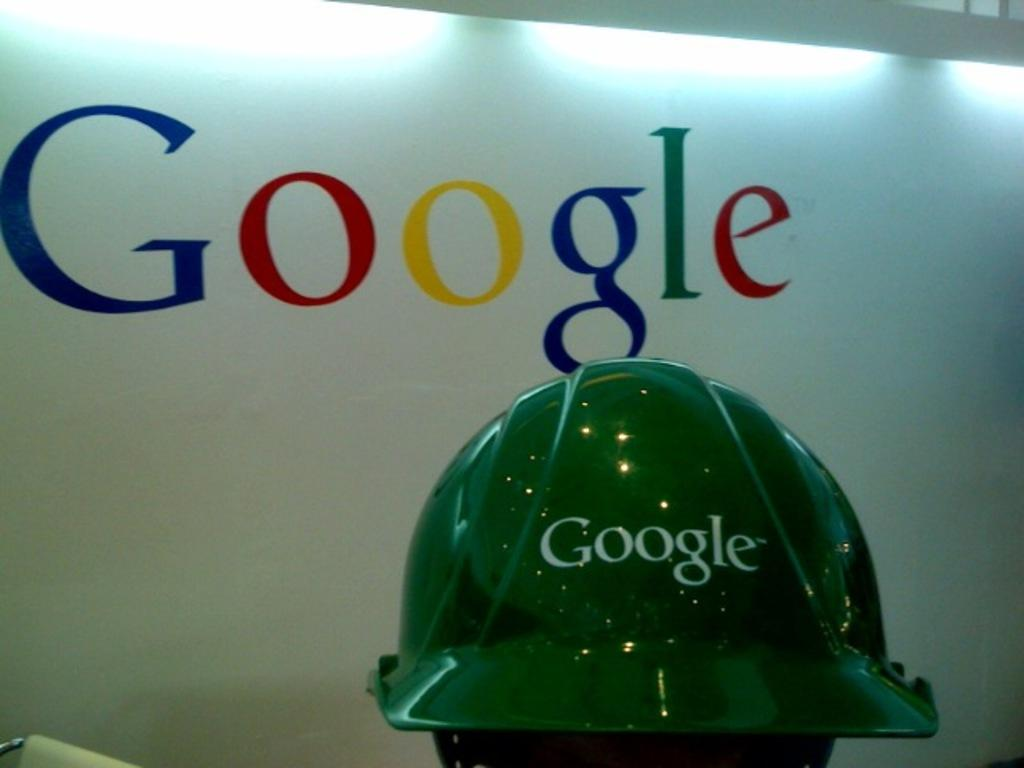What type of helmet is in the image? There is a green color helmet in the image. What can be seen on the wall in the background? The word "google" is visible on a wall in the background. What type of illumination is present in the image? There are lights present in the image. What type of loaf is being balanced on the pan in the image? There is no loaf or pan present in the image. 